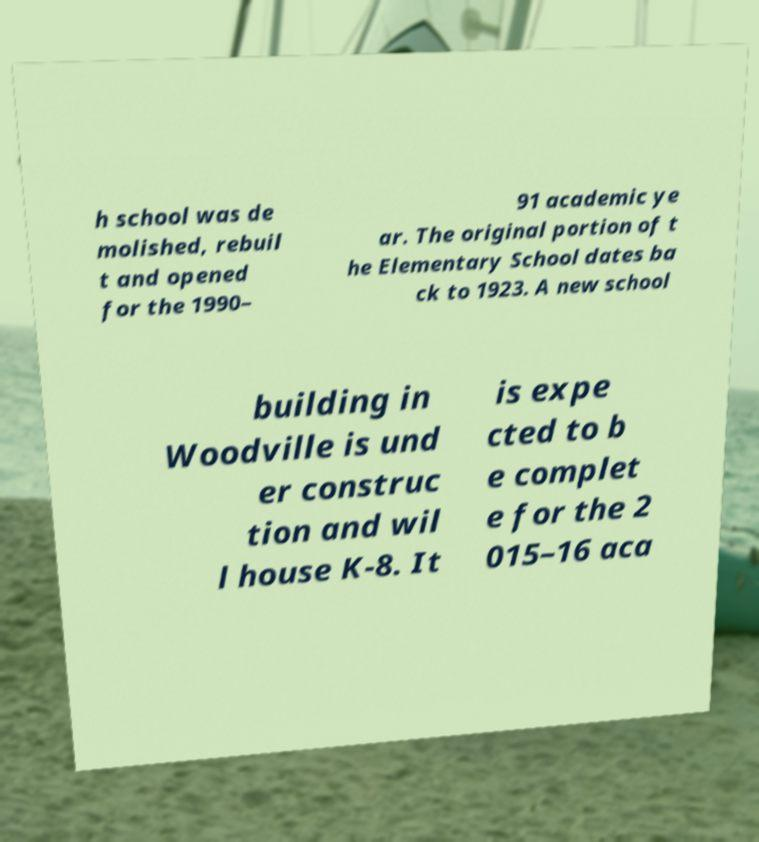For documentation purposes, I need the text within this image transcribed. Could you provide that? h school was de molished, rebuil t and opened for the 1990– 91 academic ye ar. The original portion of t he Elementary School dates ba ck to 1923. A new school building in Woodville is und er construc tion and wil l house K-8. It is expe cted to b e complet e for the 2 015–16 aca 